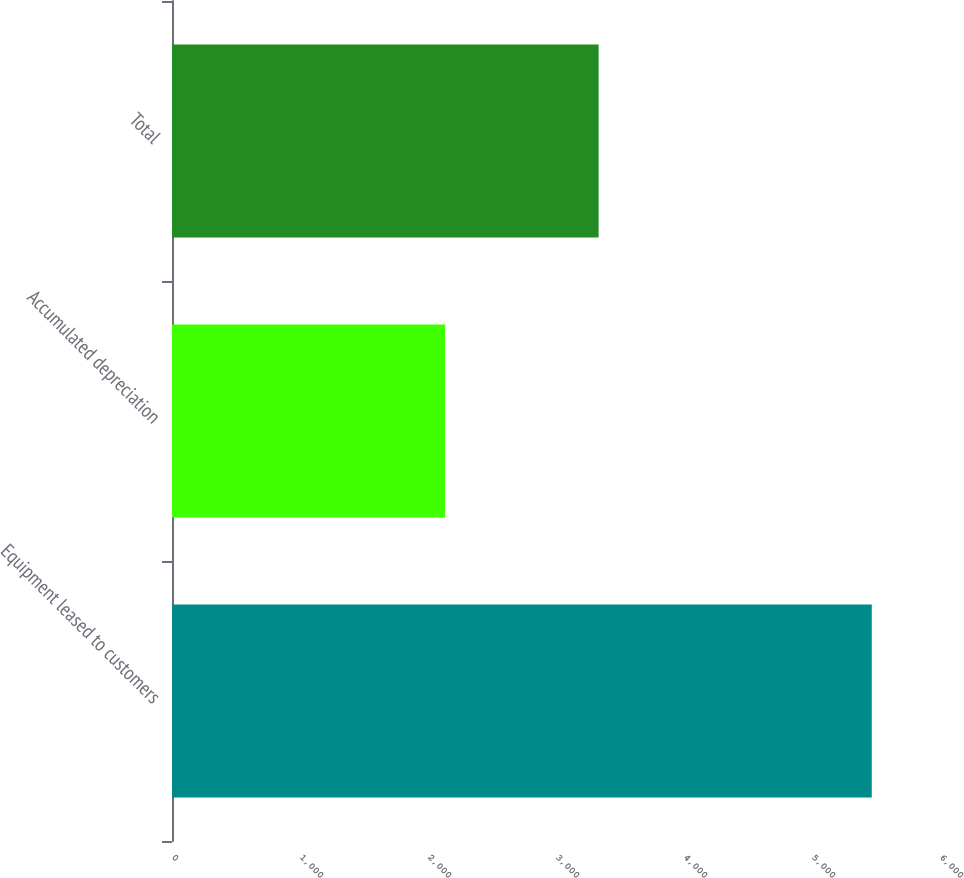Convert chart. <chart><loc_0><loc_0><loc_500><loc_500><bar_chart><fcel>Equipment leased to customers<fcel>Accumulated depreciation<fcel>Total<nl><fcel>5467<fcel>2134<fcel>3333<nl></chart> 